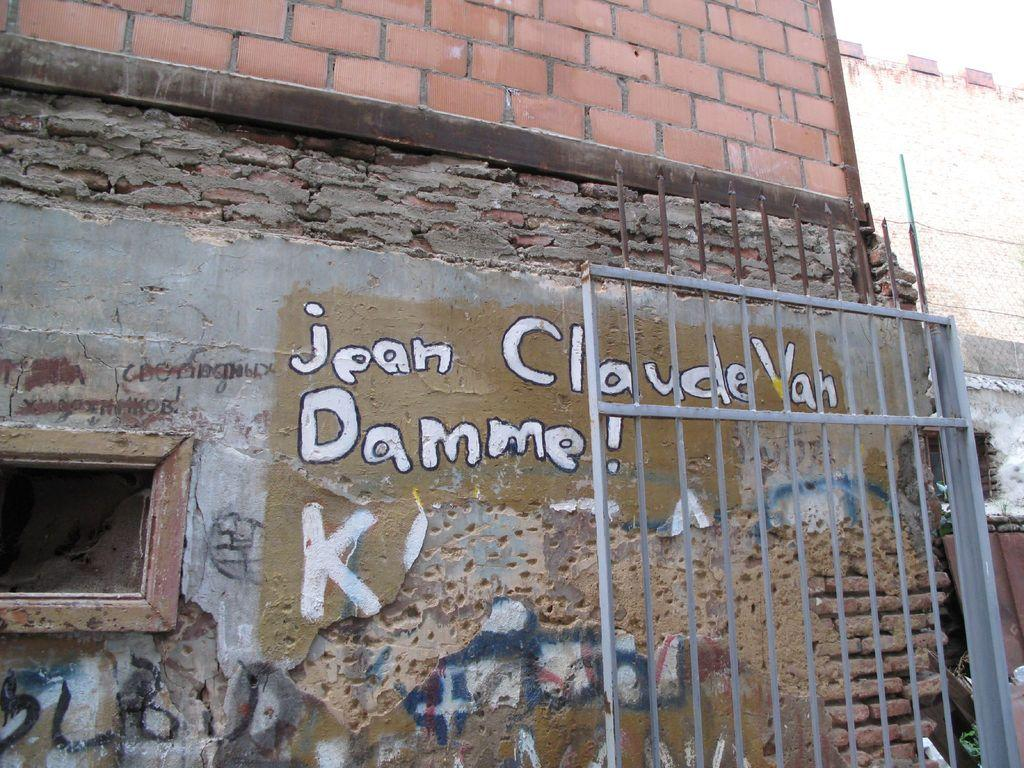What is the main structure in the center of the image? There is a building in the center of the image. What can be seen on the right side of the image? There is a gate on the right side of the image. What language is spoken by the drain in the image? There is no drain present in the image, and therefore it cannot speak any language. 